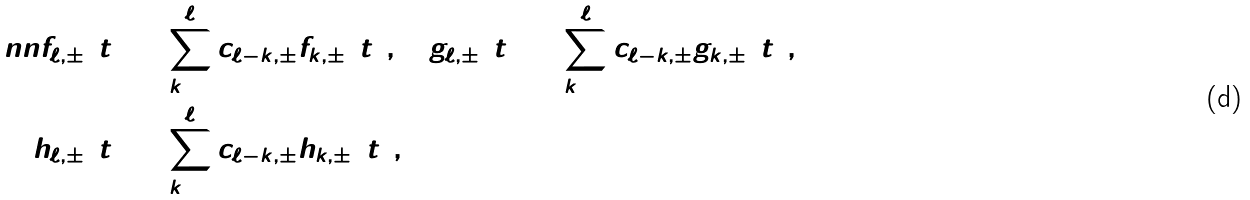<formula> <loc_0><loc_0><loc_500><loc_500>\ n n f _ { \ell , \pm } ( t ) & = \sum _ { k = 0 } ^ { \ell } c _ { \ell - k , \pm } \hat { f } _ { k , \pm } ( t ) , \quad g _ { \ell , \pm } ( t ) = \sum _ { k = 0 } ^ { \ell } c _ { \ell - k , \pm } \hat { g } _ { k , \pm } ( t ) , \\ h _ { \ell , \pm } ( t ) & = \sum _ { k = 0 } ^ { \ell } c _ { \ell - k , \pm } \hat { h } _ { k , \pm } ( t ) ,</formula> 